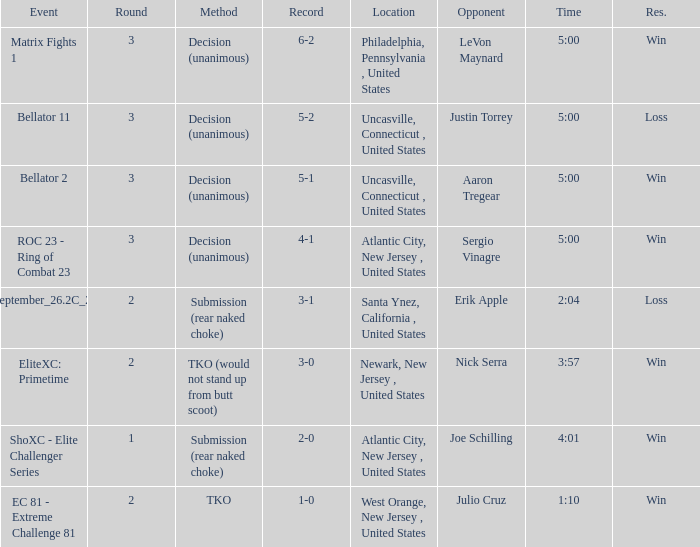Can you give me this table as a dict? {'header': ['Event', 'Round', 'Method', 'Record', 'Location', 'Opponent', 'Time', 'Res.'], 'rows': [['Matrix Fights 1', '3', 'Decision (unanimous)', '6-2', 'Philadelphia, Pennsylvania , United States', 'LeVon Maynard', '5:00', 'Win'], ['Bellator 11', '3', 'Decision (unanimous)', '5-2', 'Uncasville, Connecticut , United States', 'Justin Torrey', '5:00', 'Loss'], ['Bellator 2', '3', 'Decision (unanimous)', '5-1', 'Uncasville, Connecticut , United States', 'Aaron Tregear', '5:00', 'Win'], ['ROC 23 - Ring of Combat 23', '3', 'Decision (unanimous)', '4-1', 'Atlantic City, New Jersey , United States', 'Sergio Vinagre', '5:00', 'Win'], ['ShoXC#September_26.2C_2008_card', '2', 'Submission (rear naked choke)', '3-1', 'Santa Ynez, California , United States', 'Erik Apple', '2:04', 'Loss'], ['EliteXC: Primetime', '2', 'TKO (would not stand up from butt scoot)', '3-0', 'Newark, New Jersey , United States', 'Nick Serra', '3:57', 'Win'], ['ShoXC - Elite Challenger Series', '1', 'Submission (rear naked choke)', '2-0', 'Atlantic City, New Jersey , United States', 'Joe Schilling', '4:01', 'Win'], ['EC 81 - Extreme Challenge 81', '2', 'TKO', '1-0', 'West Orange, New Jersey , United States', 'Julio Cruz', '1:10', 'Win']]} Who was the opponent when there was a TKO method? Julio Cruz. 